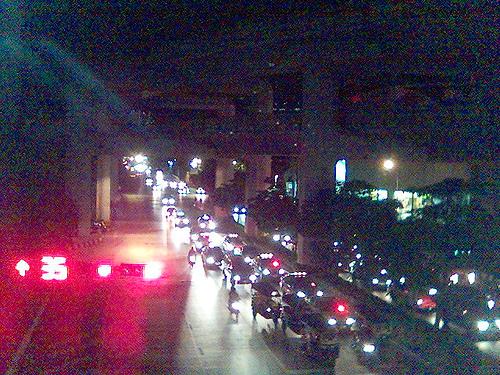What city is this?
Write a very short answer. New york. What is this road filled with?
Answer briefly. Cars. What time of day is it?
Give a very brief answer. Night. 